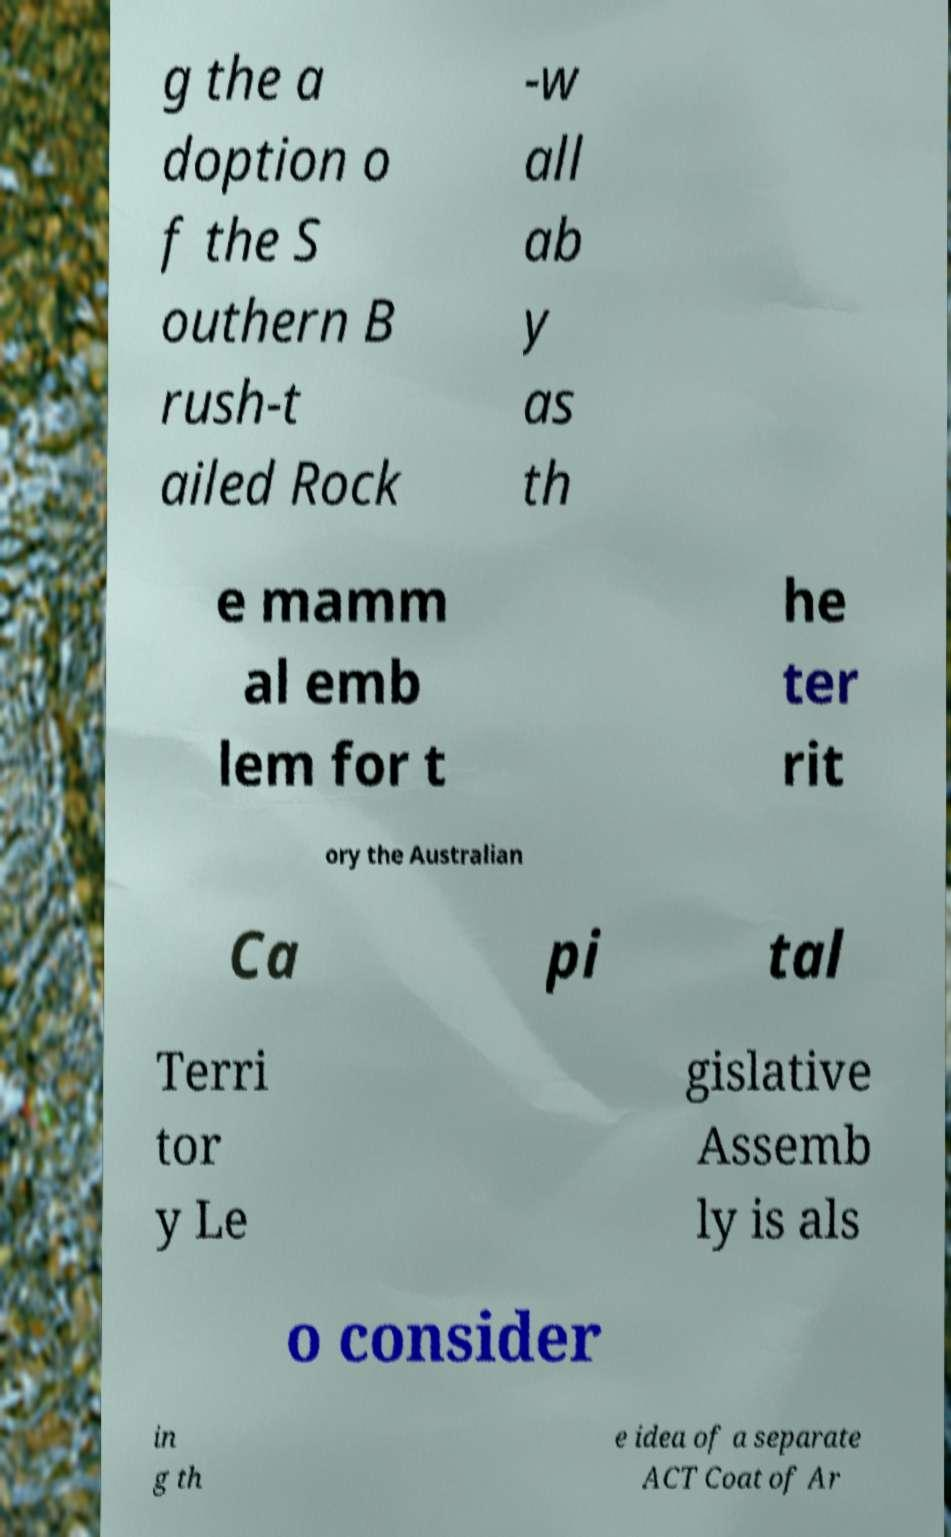For documentation purposes, I need the text within this image transcribed. Could you provide that? g the a doption o f the S outhern B rush-t ailed Rock -w all ab y as th e mamm al emb lem for t he ter rit ory the Australian Ca pi tal Terri tor y Le gislative Assemb ly is als o consider in g th e idea of a separate ACT Coat of Ar 